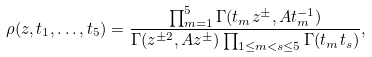<formula> <loc_0><loc_0><loc_500><loc_500>\rho ( z , t _ { 1 } , \dots , t _ { 5 } ) = \frac { \prod _ { m = 1 } ^ { 5 } \Gamma ( t _ { m } z ^ { \pm } , A t _ { m } ^ { - 1 } ) } { \Gamma ( z ^ { \pm 2 } , A z ^ { \pm } ) \prod _ { 1 \leq m < s \leq 5 } \Gamma ( t _ { m } t _ { s } ) } ,</formula> 